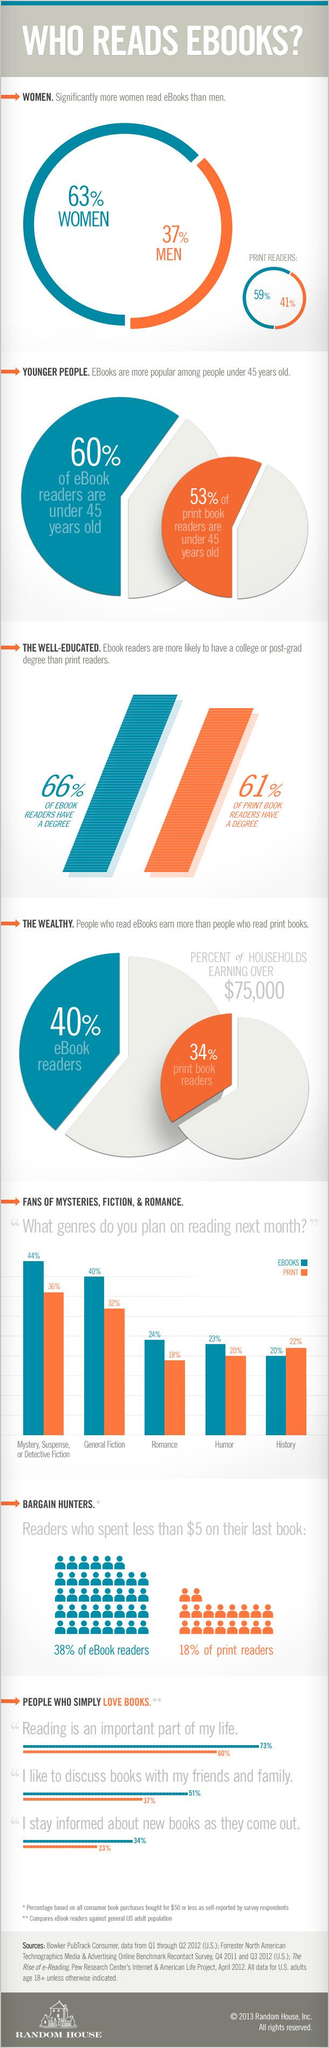Outline some significant characteristics in this image. A majority of fans of general fiction prefer ebooks. According to a survey, 66% of digital book readers have a degree. According to a recent survey, 59% of women read printed books. According to a recent study, 41% of men are print readers. According to a survey of mystery book lovers, 36% prefer printed books. 